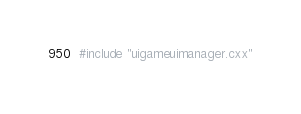Convert code to text. <code><loc_0><loc_0><loc_500><loc_500><_ObjectiveC_>#include "uigameuimanager.cxx"
</code> 